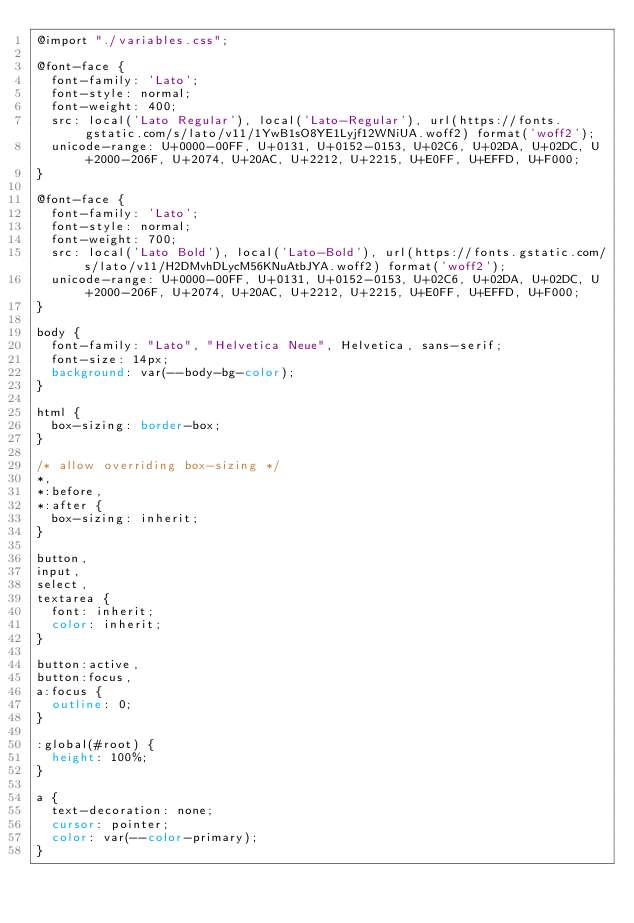<code> <loc_0><loc_0><loc_500><loc_500><_CSS_>@import "./variables.css";

@font-face {
  font-family: 'Lato';
  font-style: normal;
  font-weight: 400;
  src: local('Lato Regular'), local('Lato-Regular'), url(https://fonts.gstatic.com/s/lato/v11/1YwB1sO8YE1Lyjf12WNiUA.woff2) format('woff2');
  unicode-range: U+0000-00FF, U+0131, U+0152-0153, U+02C6, U+02DA, U+02DC, U+2000-206F, U+2074, U+20AC, U+2212, U+2215, U+E0FF, U+EFFD, U+F000;
}

@font-face {
  font-family: 'Lato';
  font-style: normal;
  font-weight: 700;
  src: local('Lato Bold'), local('Lato-Bold'), url(https://fonts.gstatic.com/s/lato/v11/H2DMvhDLycM56KNuAtbJYA.woff2) format('woff2');
  unicode-range: U+0000-00FF, U+0131, U+0152-0153, U+02C6, U+02DA, U+02DC, U+2000-206F, U+2074, U+20AC, U+2212, U+2215, U+E0FF, U+EFFD, U+F000;
}

body {
  font-family: "Lato", "Helvetica Neue", Helvetica, sans-serif;
  font-size: 14px;
  background: var(--body-bg-color);
}

html {
  box-sizing: border-box;
}

/* allow overriding box-sizing */
*,
*:before,
*:after {
  box-sizing: inherit;
}

button,
input,
select,
textarea {
  font: inherit;
  color: inherit;
}

button:active,
button:focus,
a:focus {
  outline: 0;
}

:global(#root) {
  height: 100%;
}

a {
  text-decoration: none;
  cursor: pointer;
  color: var(--color-primary);
}
</code> 